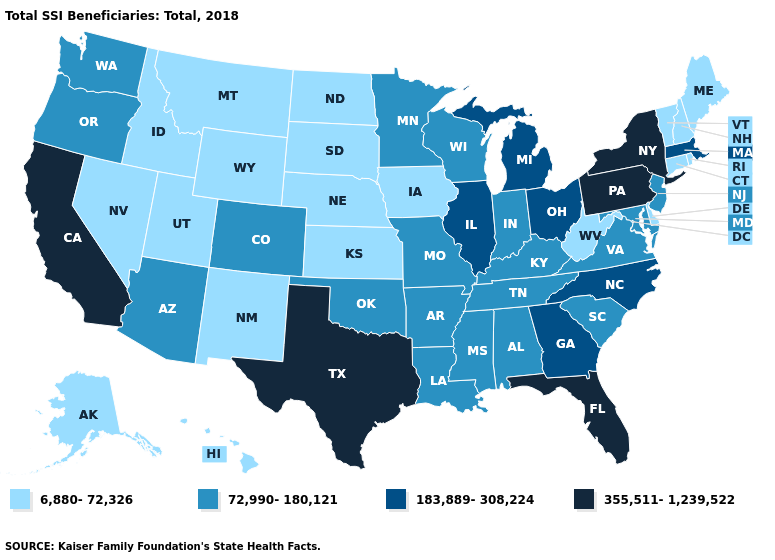What is the value of Pennsylvania?
Concise answer only. 355,511-1,239,522. Name the states that have a value in the range 355,511-1,239,522?
Write a very short answer. California, Florida, New York, Pennsylvania, Texas. What is the value of Hawaii?
Give a very brief answer. 6,880-72,326. Name the states that have a value in the range 355,511-1,239,522?
Short answer required. California, Florida, New York, Pennsylvania, Texas. What is the value of Wisconsin?
Be succinct. 72,990-180,121. What is the value of Maryland?
Write a very short answer. 72,990-180,121. Among the states that border New Mexico , does Texas have the highest value?
Answer briefly. Yes. What is the lowest value in the USA?
Write a very short answer. 6,880-72,326. Does Maine have the lowest value in the Northeast?
Be succinct. Yes. Name the states that have a value in the range 183,889-308,224?
Be succinct. Georgia, Illinois, Massachusetts, Michigan, North Carolina, Ohio. What is the value of Kansas?
Quick response, please. 6,880-72,326. What is the value of Georgia?
Write a very short answer. 183,889-308,224. Name the states that have a value in the range 183,889-308,224?
Answer briefly. Georgia, Illinois, Massachusetts, Michigan, North Carolina, Ohio. Among the states that border New York , which have the highest value?
Quick response, please. Pennsylvania. 